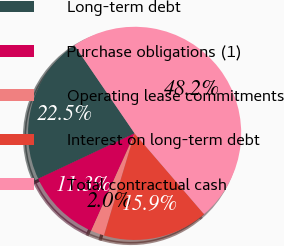Convert chart to OTSL. <chart><loc_0><loc_0><loc_500><loc_500><pie_chart><fcel>Long-term debt<fcel>Purchase obligations (1)<fcel>Operating lease commitments<fcel>Interest on long-term debt<fcel>Total contractual cash<nl><fcel>22.46%<fcel>11.32%<fcel>2.04%<fcel>15.94%<fcel>48.23%<nl></chart> 